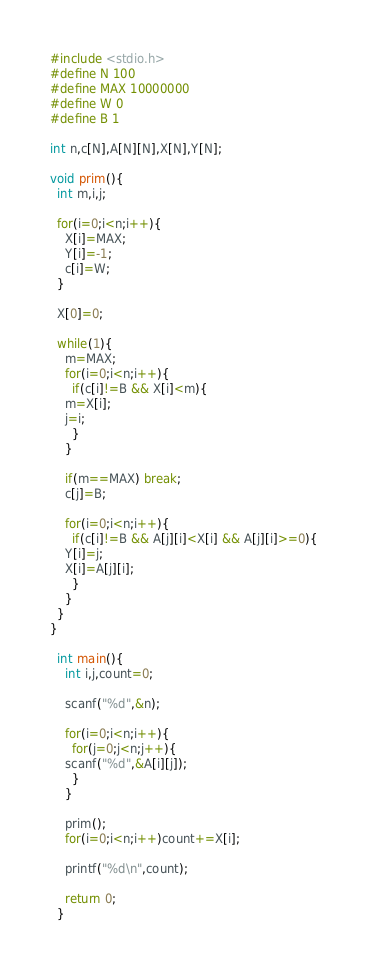<code> <loc_0><loc_0><loc_500><loc_500><_C_>#include <stdio.h>
#define N 100
#define MAX 10000000
#define W 0
#define B 1

int n,c[N],A[N][N],X[N],Y[N];

void prim(){
  int m,i,j;

  for(i=0;i<n;i++){
    X[i]=MAX;
    Y[i]=-1;
    c[i]=W;
  }

  X[0]=0;

  while(1){
    m=MAX;
    for(i=0;i<n;i++){
      if(c[i]!=B && X[i]<m){
	m=X[i];
	j=i;
      }
    }

    if(m==MAX) break;
    c[j]=B;

    for(i=0;i<n;i++){
      if(c[i]!=B && A[j][i]<X[i] && A[j][i]>=0){
	Y[i]=j;
	X[i]=A[j][i];
      }
    }
  }
}

  int main(){
    int i,j,count=0;

    scanf("%d",&n);

    for(i=0;i<n;i++){
      for(j=0;j<n;j++){
	scanf("%d",&A[i][j]);
      }
    }
    
    prim();
    for(i=0;i<n;i++)count+=X[i];

    printf("%d\n",count);

    return 0;
  }

</code> 